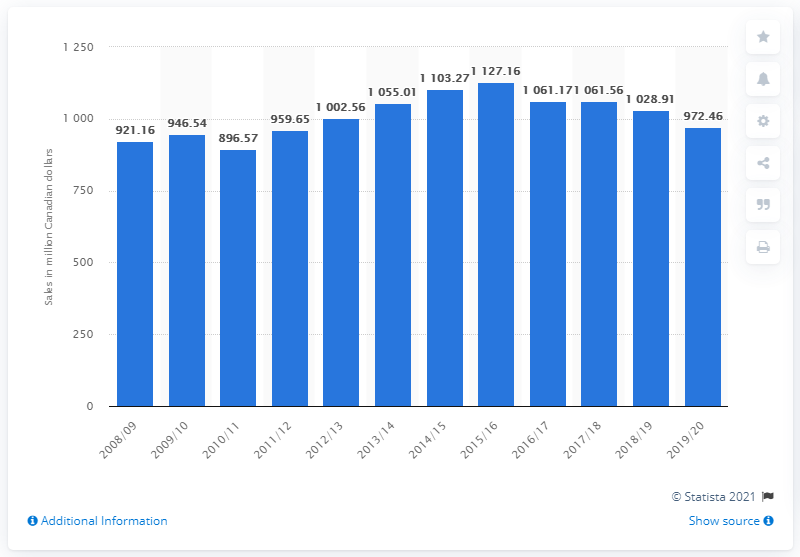Draw attention to some important aspects in this diagram. In the financial year of 2019/20, the total sales of beer in Alberta were 972.46 million units. 